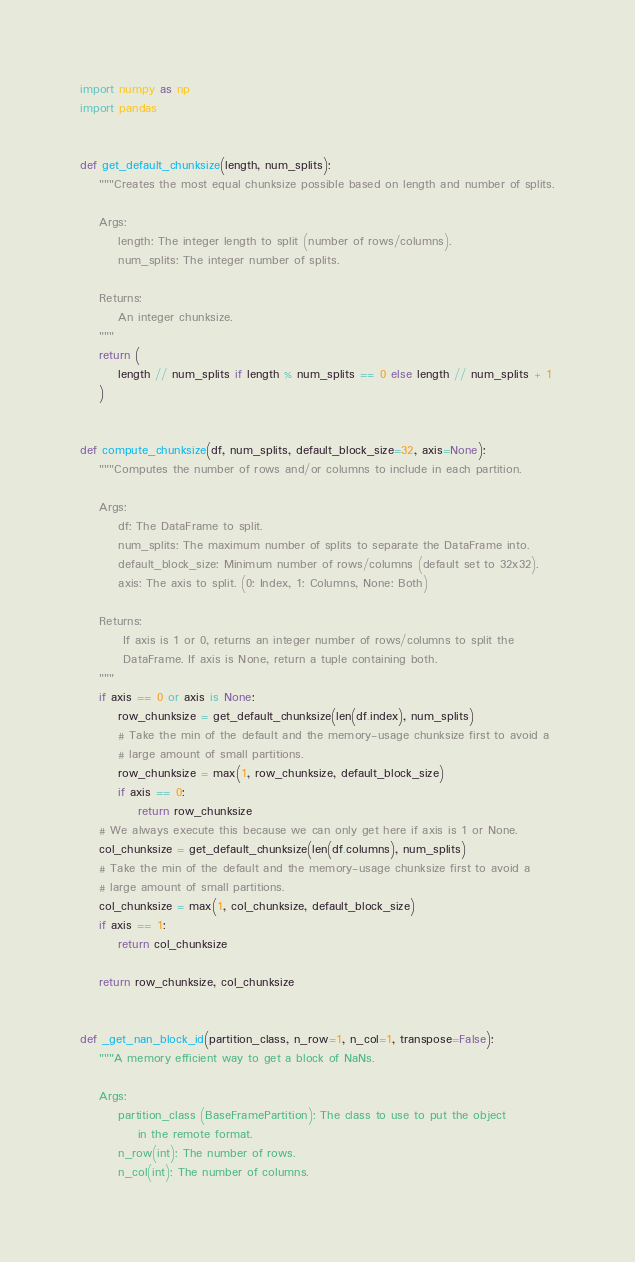<code> <loc_0><loc_0><loc_500><loc_500><_Python_>import numpy as np
import pandas


def get_default_chunksize(length, num_splits):
    """Creates the most equal chunksize possible based on length and number of splits.

    Args:
        length: The integer length to split (number of rows/columns).
        num_splits: The integer number of splits.

    Returns:
        An integer chunksize.
    """
    return (
        length // num_splits if length % num_splits == 0 else length // num_splits + 1
    )


def compute_chunksize(df, num_splits, default_block_size=32, axis=None):
    """Computes the number of rows and/or columns to include in each partition.

    Args:
        df: The DataFrame to split.
        num_splits: The maximum number of splits to separate the DataFrame into.
        default_block_size: Minimum number of rows/columns (default set to 32x32).
        axis: The axis to split. (0: Index, 1: Columns, None: Both)

    Returns:
         If axis is 1 or 0, returns an integer number of rows/columns to split the
         DataFrame. If axis is None, return a tuple containing both.
    """
    if axis == 0 or axis is None:
        row_chunksize = get_default_chunksize(len(df.index), num_splits)
        # Take the min of the default and the memory-usage chunksize first to avoid a
        # large amount of small partitions.
        row_chunksize = max(1, row_chunksize, default_block_size)
        if axis == 0:
            return row_chunksize
    # We always execute this because we can only get here if axis is 1 or None.
    col_chunksize = get_default_chunksize(len(df.columns), num_splits)
    # Take the min of the default and the memory-usage chunksize first to avoid a
    # large amount of small partitions.
    col_chunksize = max(1, col_chunksize, default_block_size)
    if axis == 1:
        return col_chunksize

    return row_chunksize, col_chunksize


def _get_nan_block_id(partition_class, n_row=1, n_col=1, transpose=False):
    """A memory efficient way to get a block of NaNs.

    Args:
        partition_class (BaseFramePartition): The class to use to put the object
            in the remote format.
        n_row(int): The number of rows.
        n_col(int): The number of columns.</code> 